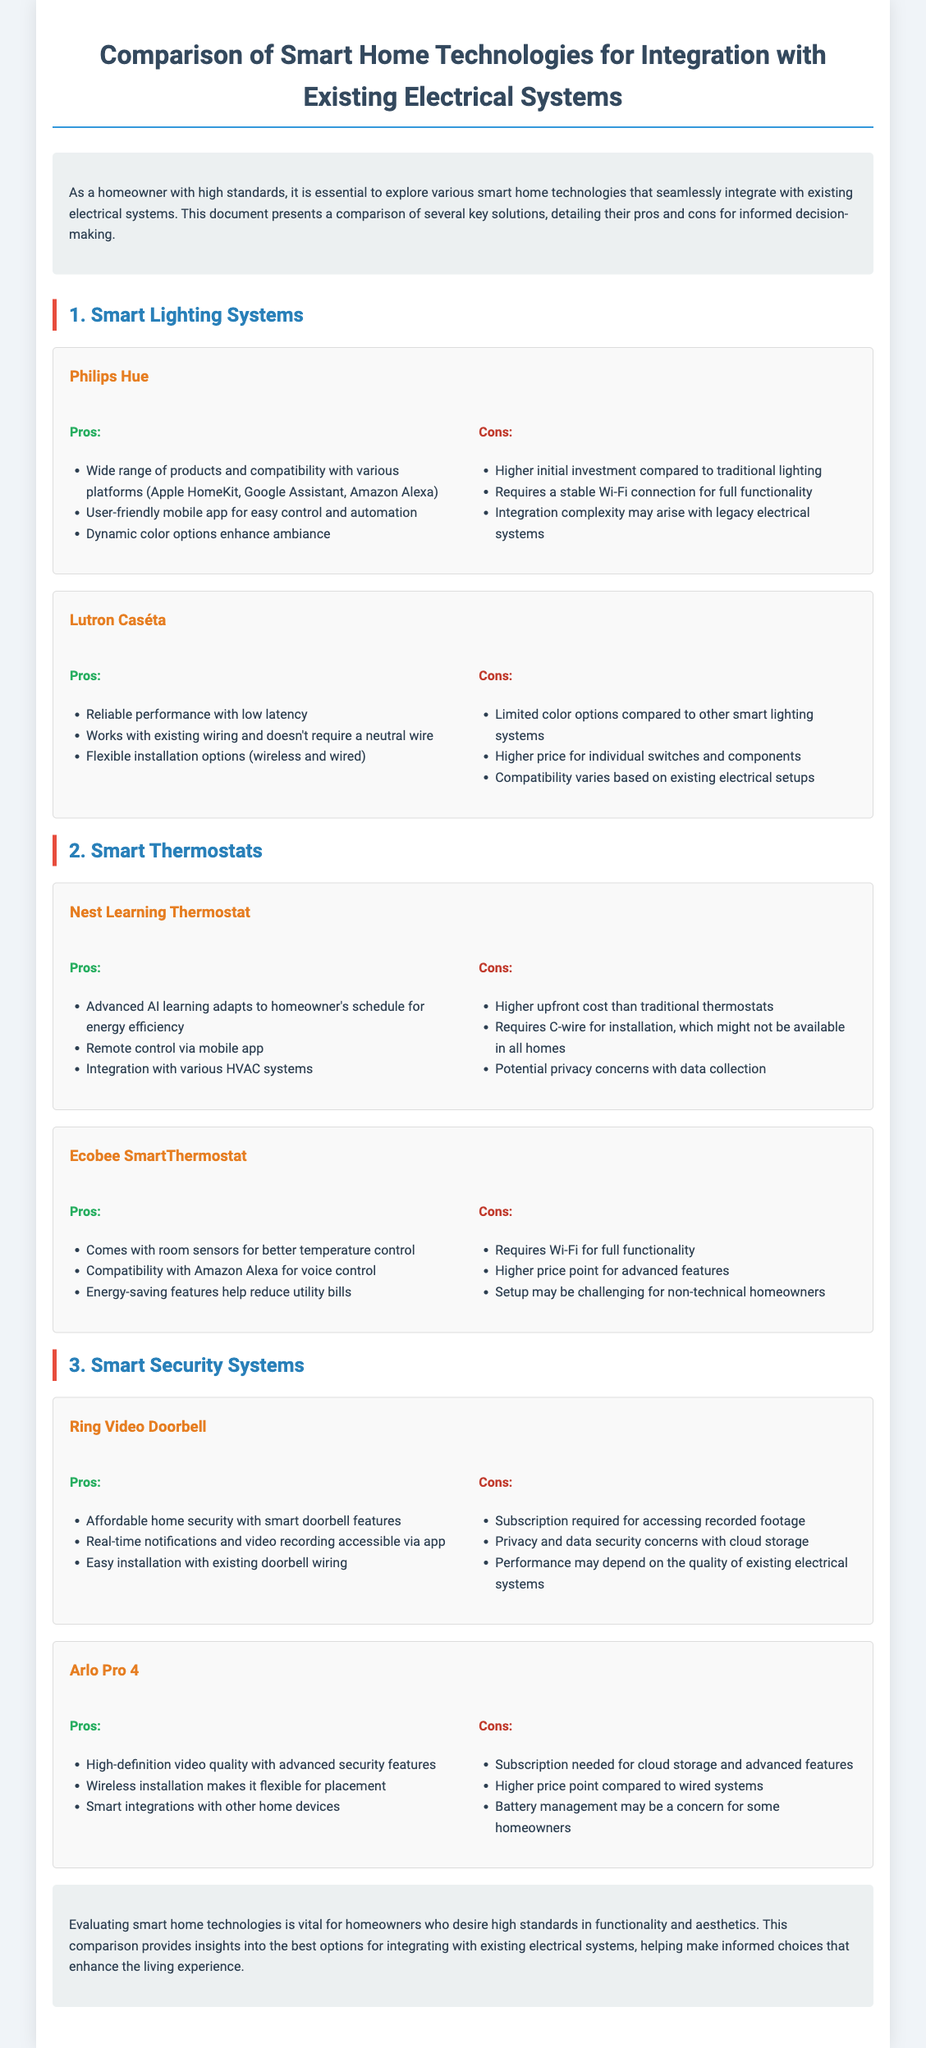What is the title of the document? The title is the main heading of the document and is provided at the top.
Answer: Comparison of Smart Home Technologies for Integration with Existing Electrical Systems What is one advantage of Philips Hue? This advantage is listed under the pros section for Philips Hue.
Answer: Wide range of products and compatibility with various platforms What is a disadvantage of Lutron Caséta? This disadvantage is mentioned in the cons section for Lutron Caséta.
Answer: Limited color options compared to other smart lighting systems Which smart thermostat does not require a C-wire for installation? This detail is provided in the pros section of Lutron Caséta.
Answer: N/A (Lutron Caséta is a smart lighting system, not a thermostat) How do Nest Learning Thermostats control energy efficiency? This information is found in the pros section for Nest Learning Thermostat and describes its functionality.
Answer: Advanced AI learning adapts to homeowner's schedule What is a feature of the Arlo Pro 4? This feature is included in the pros section of Arlo Pro 4.
Answer: High-definition video quality with advanced security features How much does the Ring Video Doorbell require for cloud storage? This requirement is stated in the cons section of Ring Video Doorbell.
Answer: Subscription required for accessing recorded footage What is a unique feature of Ecobee SmartThermostat? This feature is outlined in the pros section for Ecobee SmartThermostat.
Answer: Comes with room sensors for better temperature control What is the document's purpose? The purpose is described in the introduction of the document.
Answer: Explore various smart home technologies that seamlessly integrate with existing electrical systems 